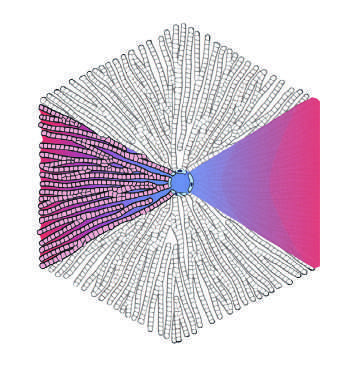how do pathologists refer to the regions of the parenchyma?
Answer the question using a single word or phrase. As periportal and centrilobular 